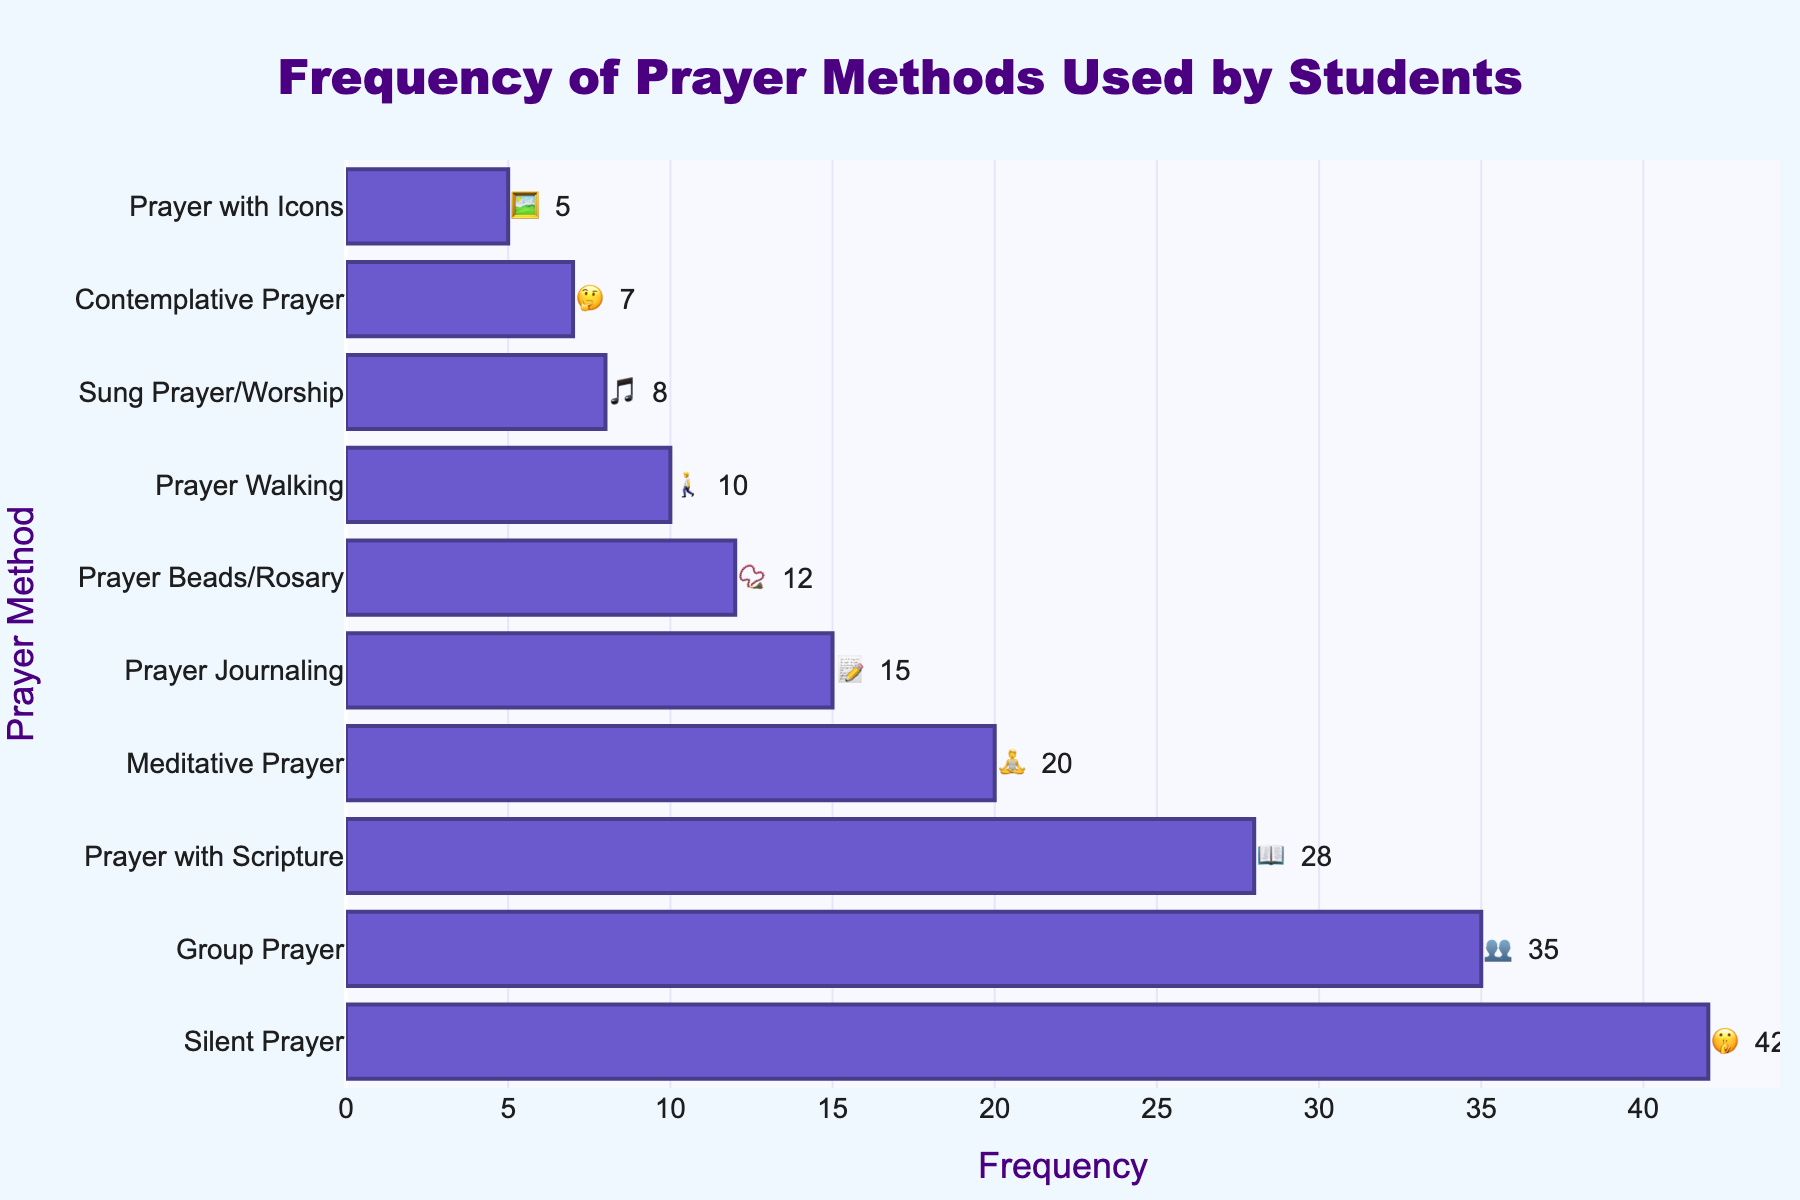What is the most frequently used prayer method shown in the figure? The figure displays various prayer methods along with their frequencies. The prayer method with the highest frequency is located at the top of the horizontal bar chart. It is represented with an emoji, and the frequency value is written next to the bar.
Answer: Silent Prayer How many students use Meditative Prayer? The figure lists the frequency of each prayer method. Locate the bar for Meditative Prayer in the chart; its frequency will be displayed next to the bar along with its emoji representation.
Answer: 20 Which is more common, Prayer Journaling or Prayer Beads/Rosary? To determine this, compare the lengths of the bars or read the frequency values next to the bars for both prayer methods. The bar with the higher value represents the more common method.
Answer: Prayer Journaling What is the total frequency of all prayer methods combined? Sum the frequency values of all the prayer methods as displayed next to each bar. This requires adding up all the given frequencies.
Answer: 182 How does the frequency of Group Prayer compare to Prayer with Scripture? Compare the frequency values of Group Prayer and Prayer with Scripture by locating their respective bars and reading the values next to them. Identify which one is higher by comparing these values.
Answer: Group Prayer What is the least frequently used prayer method shown in the figure? The prayer method with the lowest frequency will be located at the bottom of the bar chart. Identify the lowest value and note the method associated with it.
Answer: Prayer with Icons What is the difference in frequency between Silent Prayer and Meditative Prayer? Find the frequency values for both Silent Prayer and Meditative Prayer and subtract the lower value from the higher value. Silent Prayer has 42, and Meditative Prayer has 20. The difference is 42 - 20.
Answer: 22 How many prayer methods have a frequency of 10 or less? Go through the list of prayer methods in the figure and count how many of them have a frequency value that is 10 or less.
Answer: 4 Which prayer method represented with the 📝 emoji, and how frequent is it? Look for the emoji 📝 in the figure and identify the associated prayer method and its frequency, which will be displayed next to the bar.
Answer: Prayer Journaling, 15 What is the average frequency of the prayer methods listed in the figure? To find the average, sum up all the frequency values and divide by the number of prayer methods. The sum is 182 and the number of methods is 10. The average is 182 / 10.
Answer: 18.2 